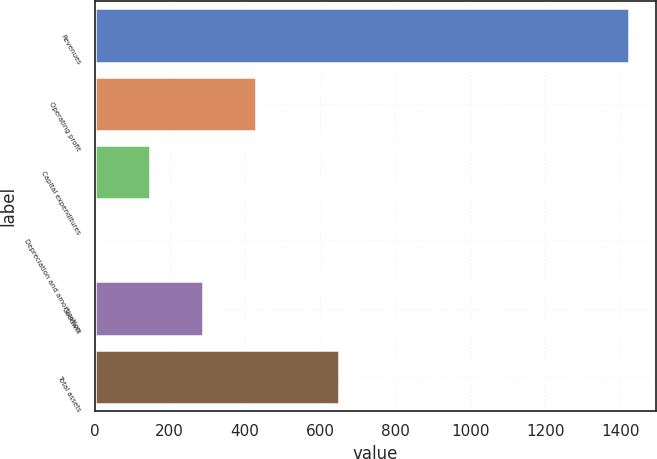Convert chart to OTSL. <chart><loc_0><loc_0><loc_500><loc_500><bar_chart><fcel>Revenues<fcel>Operating profit<fcel>Capital expenditures<fcel>Depreciation and amortization<fcel>Goodwill<fcel>Total assets<nl><fcel>1423.7<fcel>430.61<fcel>146.87<fcel>5<fcel>288.74<fcel>651.8<nl></chart> 